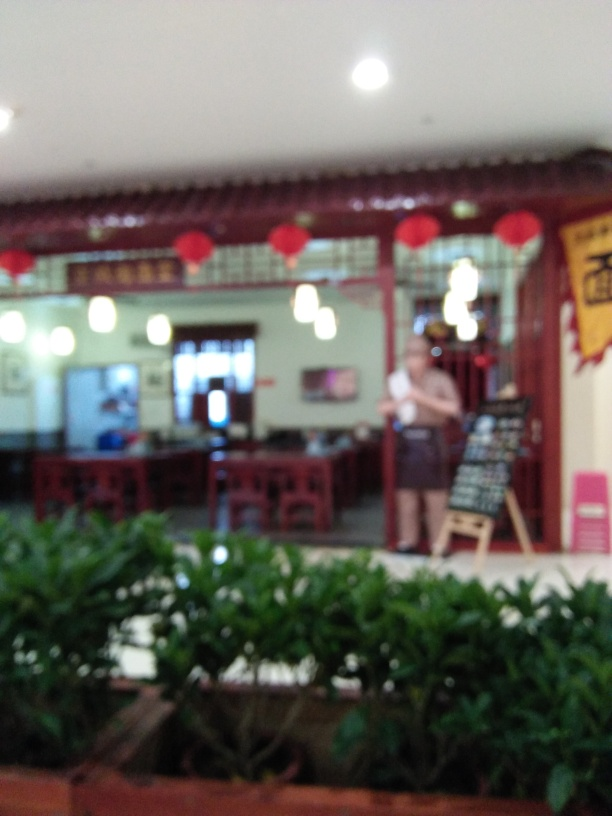Can you comment on the lighting in the room? The image presents an interior space illuminated primarily by overhead lighting, which casts a soft glow throughout the room. There appears to be natural light coming from a door or window in the background, suggesting an additional source of lighting that contributes to the overall ambience. 